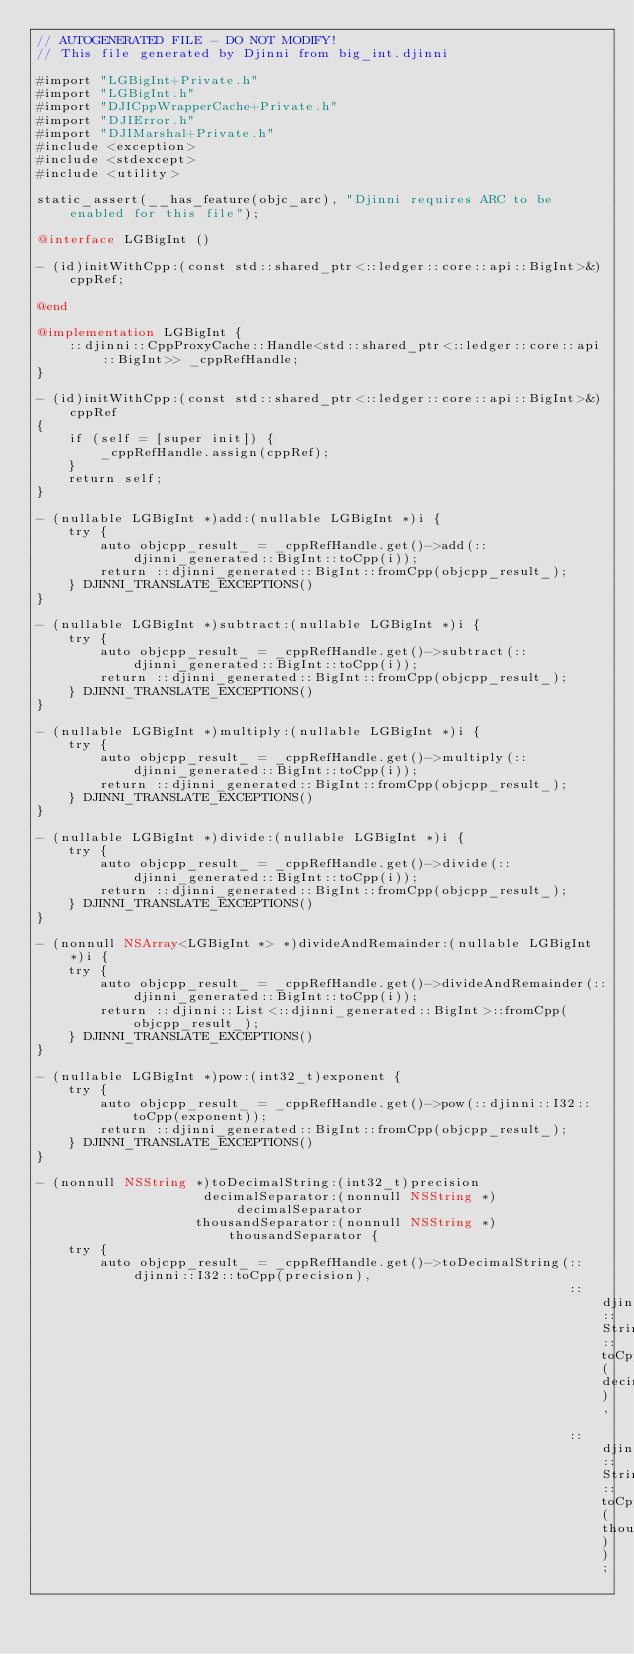Convert code to text. <code><loc_0><loc_0><loc_500><loc_500><_ObjectiveC_>// AUTOGENERATED FILE - DO NOT MODIFY!
// This file generated by Djinni from big_int.djinni

#import "LGBigInt+Private.h"
#import "LGBigInt.h"
#import "DJICppWrapperCache+Private.h"
#import "DJIError.h"
#import "DJIMarshal+Private.h"
#include <exception>
#include <stdexcept>
#include <utility>

static_assert(__has_feature(objc_arc), "Djinni requires ARC to be enabled for this file");

@interface LGBigInt ()

- (id)initWithCpp:(const std::shared_ptr<::ledger::core::api::BigInt>&)cppRef;

@end

@implementation LGBigInt {
    ::djinni::CppProxyCache::Handle<std::shared_ptr<::ledger::core::api::BigInt>> _cppRefHandle;
}

- (id)initWithCpp:(const std::shared_ptr<::ledger::core::api::BigInt>&)cppRef
{
    if (self = [super init]) {
        _cppRefHandle.assign(cppRef);
    }
    return self;
}

- (nullable LGBigInt *)add:(nullable LGBigInt *)i {
    try {
        auto objcpp_result_ = _cppRefHandle.get()->add(::djinni_generated::BigInt::toCpp(i));
        return ::djinni_generated::BigInt::fromCpp(objcpp_result_);
    } DJINNI_TRANSLATE_EXCEPTIONS()
}

- (nullable LGBigInt *)subtract:(nullable LGBigInt *)i {
    try {
        auto objcpp_result_ = _cppRefHandle.get()->subtract(::djinni_generated::BigInt::toCpp(i));
        return ::djinni_generated::BigInt::fromCpp(objcpp_result_);
    } DJINNI_TRANSLATE_EXCEPTIONS()
}

- (nullable LGBigInt *)multiply:(nullable LGBigInt *)i {
    try {
        auto objcpp_result_ = _cppRefHandle.get()->multiply(::djinni_generated::BigInt::toCpp(i));
        return ::djinni_generated::BigInt::fromCpp(objcpp_result_);
    } DJINNI_TRANSLATE_EXCEPTIONS()
}

- (nullable LGBigInt *)divide:(nullable LGBigInt *)i {
    try {
        auto objcpp_result_ = _cppRefHandle.get()->divide(::djinni_generated::BigInt::toCpp(i));
        return ::djinni_generated::BigInt::fromCpp(objcpp_result_);
    } DJINNI_TRANSLATE_EXCEPTIONS()
}

- (nonnull NSArray<LGBigInt *> *)divideAndRemainder:(nullable LGBigInt *)i {
    try {
        auto objcpp_result_ = _cppRefHandle.get()->divideAndRemainder(::djinni_generated::BigInt::toCpp(i));
        return ::djinni::List<::djinni_generated::BigInt>::fromCpp(objcpp_result_);
    } DJINNI_TRANSLATE_EXCEPTIONS()
}

- (nullable LGBigInt *)pow:(int32_t)exponent {
    try {
        auto objcpp_result_ = _cppRefHandle.get()->pow(::djinni::I32::toCpp(exponent));
        return ::djinni_generated::BigInt::fromCpp(objcpp_result_);
    } DJINNI_TRANSLATE_EXCEPTIONS()
}

- (nonnull NSString *)toDecimalString:(int32_t)precision
                     decimalSeparator:(nonnull NSString *)decimalSeparator
                    thousandSeparator:(nonnull NSString *)thousandSeparator {
    try {
        auto objcpp_result_ = _cppRefHandle.get()->toDecimalString(::djinni::I32::toCpp(precision),
                                                                   ::djinni::String::toCpp(decimalSeparator),
                                                                   ::djinni::String::toCpp(thousandSeparator));</code> 